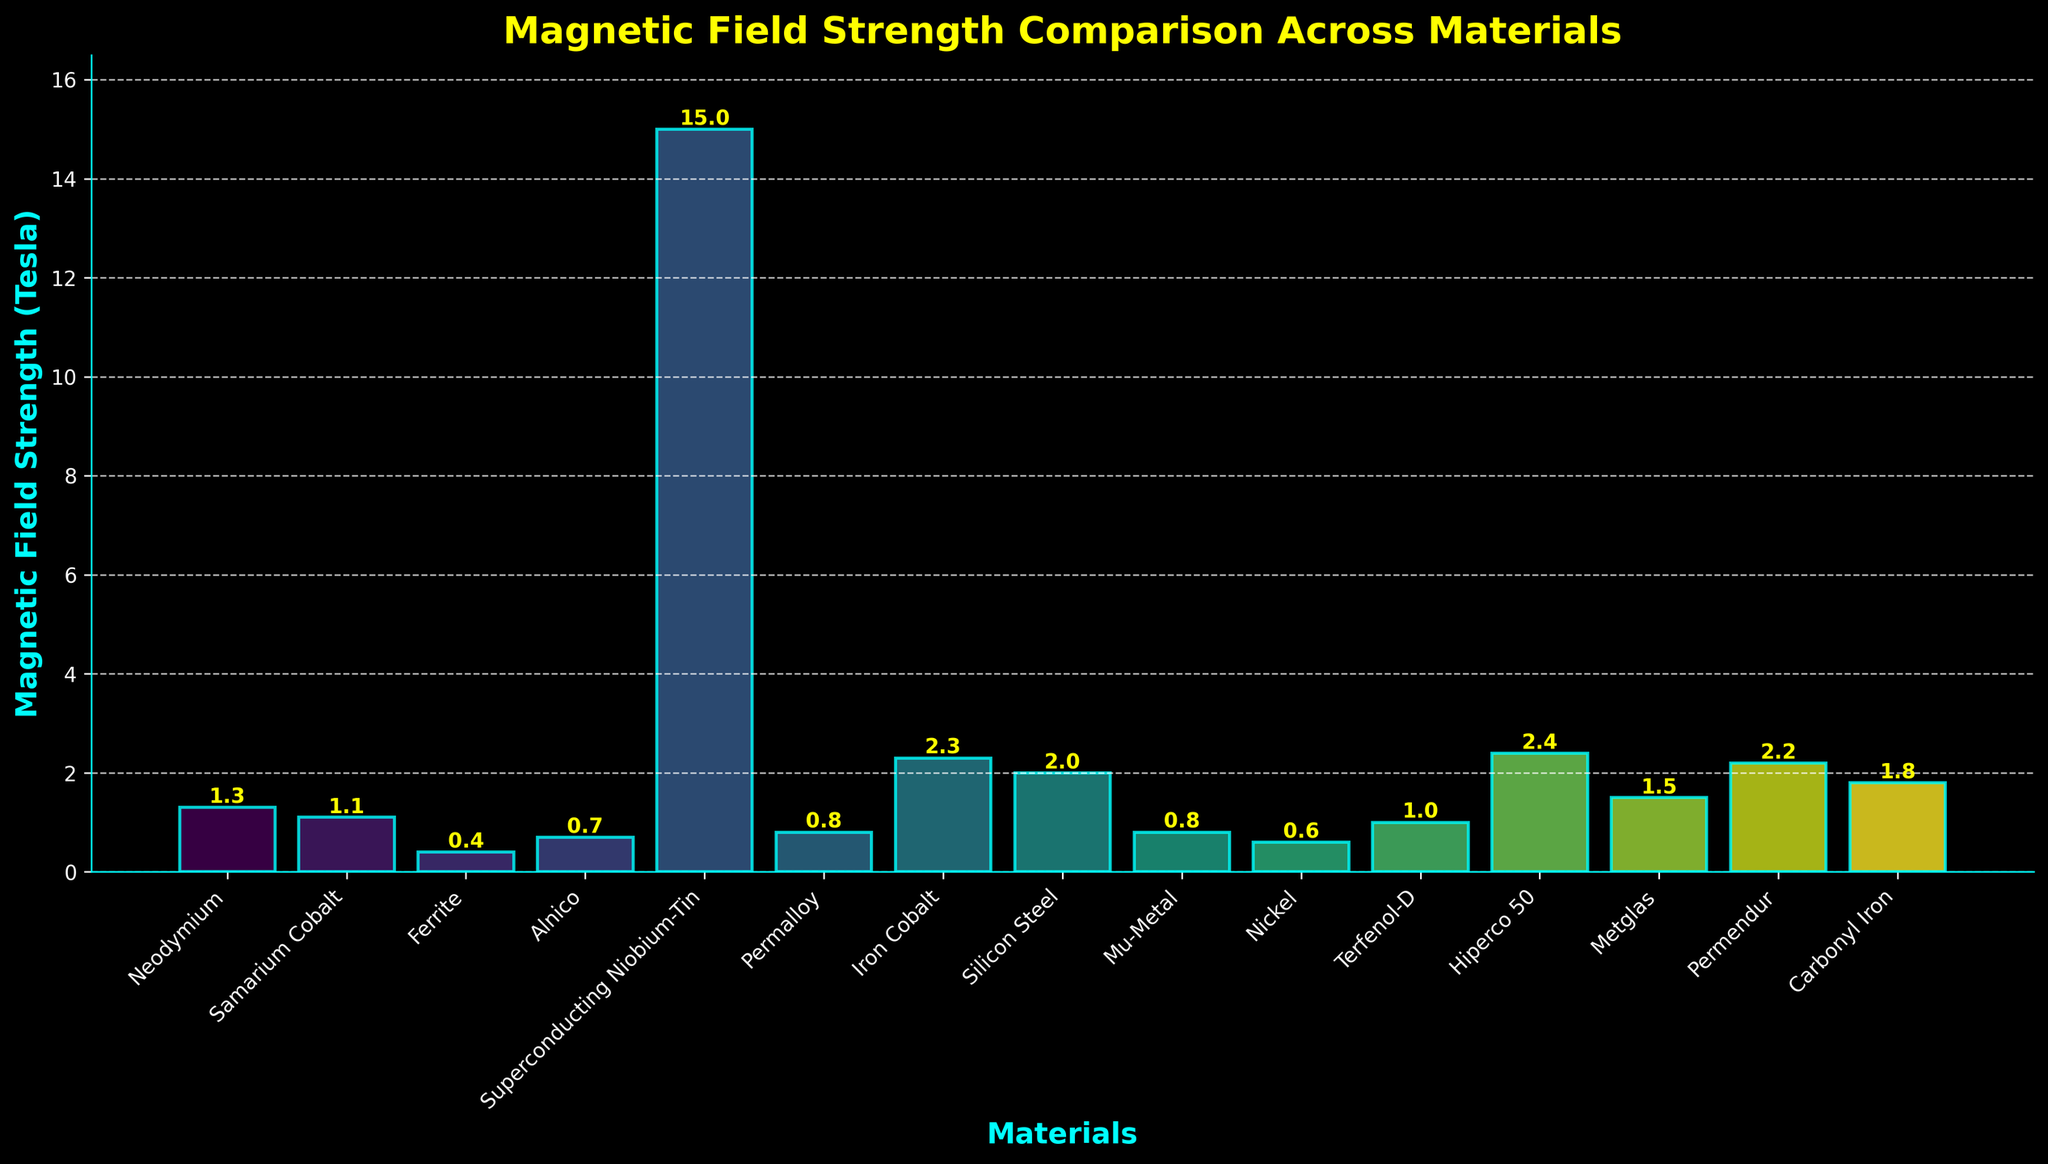Which material has the highest magnetic field strength? By examining the figure, it is evident that the bar representing superconducting niobium-tin is the tallest, indicating it has the highest magnetic field strength.
Answer: Superconducting Niobium-Tin What is the difference in magnetic field strength between Hiperco 50 and Alnico? From the figure, the magnetic field strength of Hiperco 50 is 2.4 Tesla and that of Alnico is 0.7 Tesla. The difference is calculated as 2.4 - 0.7.
Answer: 1.7 Tesla Which material has a magnetic field strength closest to 1 Tesla? The bar representing Terfenol-D closely aligns with 1 Tesla, making it the closest.
Answer: Terfenol-D How many materials have a magnetic field strength of 0.8 Tesla? By looking at the figure, we see that both Permalloy and Mu-Metal have bars that reach 0.8 Tesla.
Answer: 2 materials Is the magnetic field strength of Ferrite greater than Nickel? Observing the heights of the bars, the Ferrite bar is higher at 0.4 Tesla compared to the Nickel bar at 0.6 Tesla, meaning the statement is false.
Answer: No Rank the top three materials with the highest magnetic field strength. By arranging the materials by the bar heights, the top three materials are Hiperco 50 (2.4 Tesla), Iron Cobalt (2.3 Tesla), and Permendur (2.2 Tesla).
Answer: Hiperco 50, Iron Cobalt, Permendur What is the average magnetic field strength of Superconducting Niobium-Tin, Hiperco 50, and Metglas? Adding up their strengths: 15.0 (Superconducting Niobium-Tin) + 2.4 (Hiperco 50) + 1.5 (Metglas) gives 18.9. Dividing by 3 results in 18.9 / 3.
Answer: 6.3 Tesla What is the total magnetic field strength of all materials combined? Summing up all the magnetic field strengths from each material from the figure: 1.3 + 1.1 + 0.4 + 0.7 + 15.0 + 0.8 + 2.3 + 2.0 + 0.8 + 0.6 + 1.0 + 2.4 + 1.5 + 2.2 + 1.8 results in a total of 33.9.
Answer: 33.9 Tesla Does Silicon Steel have a higher magnetic field strength than Ferrite? Checking the heights of their respective bars, Silicon Steel (2.0 Tesla) is higher compared to Ferrite (0.4 Tesla).
Answer: Yes Which material's bar is colored similarly to Mu-Metal? By visually comparing the colors of the bars, both Mu-Metal and Permalloy share similar color tones.
Answer: Permalloy 